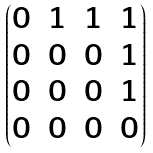Convert formula to latex. <formula><loc_0><loc_0><loc_500><loc_500>\begin{pmatrix} 0 & 1 & 1 & 1 \\ 0 & 0 & 0 & 1 \\ 0 & 0 & 0 & 1 \\ 0 & 0 & 0 & 0 \end{pmatrix}</formula> 